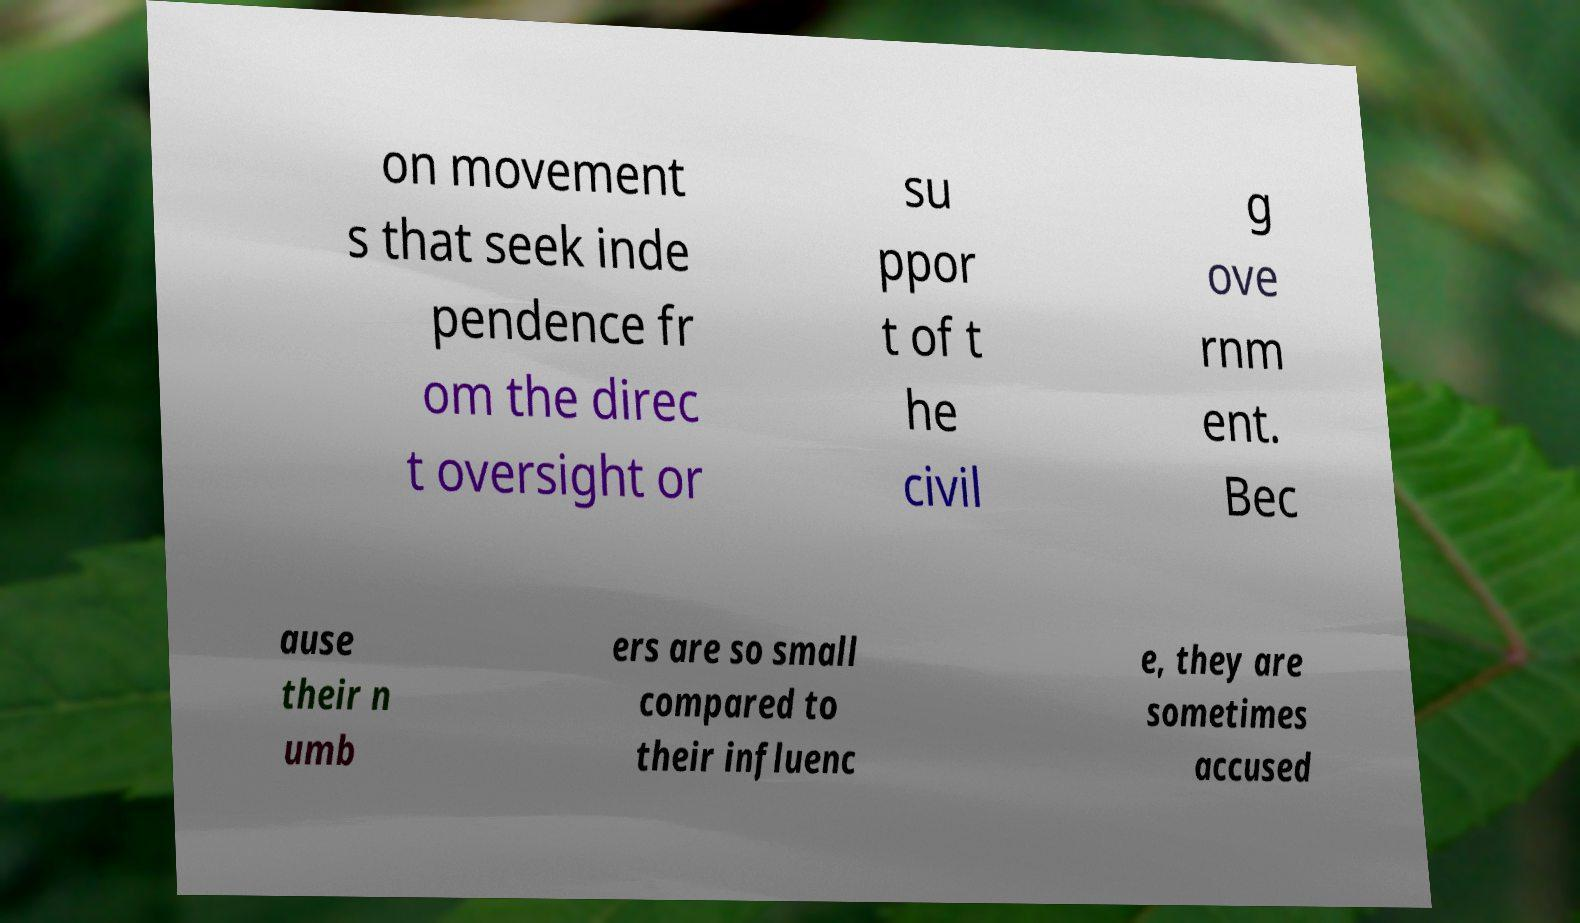Please read and relay the text visible in this image. What does it say? on movement s that seek inde pendence fr om the direc t oversight or su ppor t of t he civil g ove rnm ent. Bec ause their n umb ers are so small compared to their influenc e, they are sometimes accused 